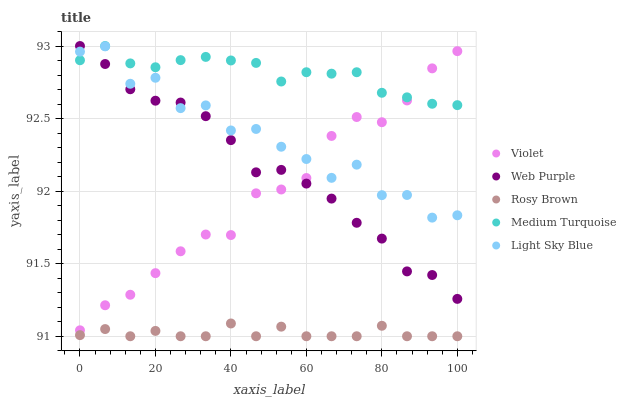Does Rosy Brown have the minimum area under the curve?
Answer yes or no. Yes. Does Medium Turquoise have the maximum area under the curve?
Answer yes or no. Yes. Does Web Purple have the minimum area under the curve?
Answer yes or no. No. Does Web Purple have the maximum area under the curve?
Answer yes or no. No. Is Medium Turquoise the smoothest?
Answer yes or no. Yes. Is Light Sky Blue the roughest?
Answer yes or no. Yes. Is Web Purple the smoothest?
Answer yes or no. No. Is Web Purple the roughest?
Answer yes or no. No. Does Rosy Brown have the lowest value?
Answer yes or no. Yes. Does Web Purple have the lowest value?
Answer yes or no. No. Does Medium Turquoise have the highest value?
Answer yes or no. Yes. Does Rosy Brown have the highest value?
Answer yes or no. No. Is Rosy Brown less than Light Sky Blue?
Answer yes or no. Yes. Is Violet greater than Rosy Brown?
Answer yes or no. Yes. Does Light Sky Blue intersect Violet?
Answer yes or no. Yes. Is Light Sky Blue less than Violet?
Answer yes or no. No. Is Light Sky Blue greater than Violet?
Answer yes or no. No. Does Rosy Brown intersect Light Sky Blue?
Answer yes or no. No. 